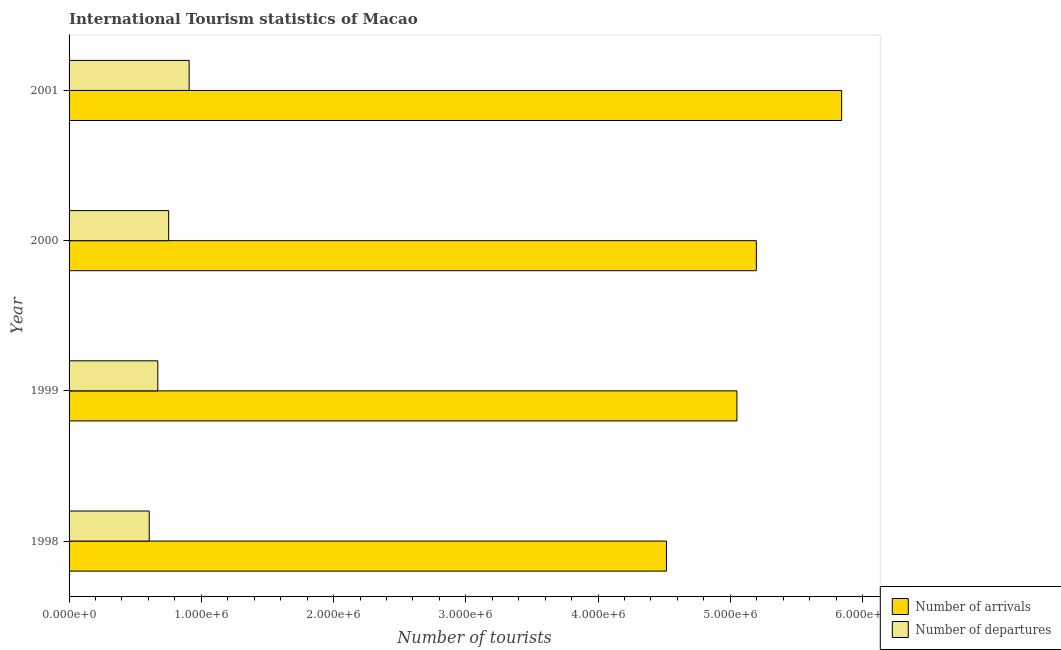Are the number of bars on each tick of the Y-axis equal?
Make the answer very short. Yes. How many bars are there on the 1st tick from the top?
Provide a short and direct response. 2. How many bars are there on the 4th tick from the bottom?
Give a very brief answer. 2. What is the label of the 1st group of bars from the top?
Ensure brevity in your answer.  2001. What is the number of tourist arrivals in 1999?
Your response must be concise. 5.05e+06. Across all years, what is the maximum number of tourist arrivals?
Your answer should be compact. 5.84e+06. Across all years, what is the minimum number of tourist departures?
Your answer should be compact. 6.06e+05. In which year was the number of tourist arrivals maximum?
Your answer should be very brief. 2001. What is the total number of tourist arrivals in the graph?
Your answer should be very brief. 2.06e+07. What is the difference between the number of tourist arrivals in 1998 and that in 2001?
Keep it short and to the point. -1.32e+06. What is the difference between the number of tourist arrivals in 1998 and the number of tourist departures in 2000?
Give a very brief answer. 3.76e+06. What is the average number of tourist arrivals per year?
Your answer should be very brief. 5.15e+06. In the year 1999, what is the difference between the number of tourist arrivals and number of tourist departures?
Your answer should be compact. 4.38e+06. In how many years, is the number of tourist arrivals greater than 400000 ?
Your answer should be very brief. 4. What is the ratio of the number of tourist arrivals in 2000 to that in 2001?
Make the answer very short. 0.89. Is the number of tourist departures in 1998 less than that in 1999?
Offer a very short reply. Yes. Is the difference between the number of tourist departures in 2000 and 2001 greater than the difference between the number of tourist arrivals in 2000 and 2001?
Offer a terse response. Yes. What is the difference between the highest and the second highest number of tourist arrivals?
Keep it short and to the point. 6.45e+05. What is the difference between the highest and the lowest number of tourist arrivals?
Ensure brevity in your answer.  1.32e+06. In how many years, is the number of tourist arrivals greater than the average number of tourist arrivals taken over all years?
Ensure brevity in your answer.  2. Is the sum of the number of tourist arrivals in 2000 and 2001 greater than the maximum number of tourist departures across all years?
Your answer should be very brief. Yes. What does the 1st bar from the top in 1998 represents?
Your answer should be very brief. Number of departures. What does the 1st bar from the bottom in 2001 represents?
Offer a very short reply. Number of arrivals. Are all the bars in the graph horizontal?
Provide a succinct answer. Yes. How many years are there in the graph?
Make the answer very short. 4. Does the graph contain grids?
Keep it short and to the point. No. Where does the legend appear in the graph?
Offer a terse response. Bottom right. How are the legend labels stacked?
Provide a short and direct response. Vertical. What is the title of the graph?
Keep it short and to the point. International Tourism statistics of Macao. Does "Non-pregnant women" appear as one of the legend labels in the graph?
Make the answer very short. No. What is the label or title of the X-axis?
Provide a short and direct response. Number of tourists. What is the label or title of the Y-axis?
Ensure brevity in your answer.  Year. What is the Number of tourists of Number of arrivals in 1998?
Your response must be concise. 4.52e+06. What is the Number of tourists of Number of departures in 1998?
Your response must be concise. 6.06e+05. What is the Number of tourists in Number of arrivals in 1999?
Your answer should be very brief. 5.05e+06. What is the Number of tourists in Number of departures in 1999?
Offer a very short reply. 6.71e+05. What is the Number of tourists of Number of arrivals in 2000?
Offer a very short reply. 5.20e+06. What is the Number of tourists of Number of departures in 2000?
Your response must be concise. 7.53e+05. What is the Number of tourists of Number of arrivals in 2001?
Your answer should be very brief. 5.84e+06. What is the Number of tourists of Number of departures in 2001?
Offer a terse response. 9.08e+05. Across all years, what is the maximum Number of tourists in Number of arrivals?
Your answer should be compact. 5.84e+06. Across all years, what is the maximum Number of tourists in Number of departures?
Make the answer very short. 9.08e+05. Across all years, what is the minimum Number of tourists of Number of arrivals?
Ensure brevity in your answer.  4.52e+06. Across all years, what is the minimum Number of tourists in Number of departures?
Your answer should be compact. 6.06e+05. What is the total Number of tourists of Number of arrivals in the graph?
Offer a terse response. 2.06e+07. What is the total Number of tourists in Number of departures in the graph?
Provide a short and direct response. 2.94e+06. What is the difference between the Number of tourists of Number of arrivals in 1998 and that in 1999?
Your answer should be very brief. -5.33e+05. What is the difference between the Number of tourists of Number of departures in 1998 and that in 1999?
Keep it short and to the point. -6.50e+04. What is the difference between the Number of tourists of Number of arrivals in 1998 and that in 2000?
Offer a terse response. -6.80e+05. What is the difference between the Number of tourists in Number of departures in 1998 and that in 2000?
Make the answer very short. -1.47e+05. What is the difference between the Number of tourists in Number of arrivals in 1998 and that in 2001?
Give a very brief answer. -1.32e+06. What is the difference between the Number of tourists of Number of departures in 1998 and that in 2001?
Offer a very short reply. -3.02e+05. What is the difference between the Number of tourists of Number of arrivals in 1999 and that in 2000?
Provide a short and direct response. -1.47e+05. What is the difference between the Number of tourists in Number of departures in 1999 and that in 2000?
Offer a very short reply. -8.20e+04. What is the difference between the Number of tourists of Number of arrivals in 1999 and that in 2001?
Give a very brief answer. -7.92e+05. What is the difference between the Number of tourists of Number of departures in 1999 and that in 2001?
Provide a succinct answer. -2.37e+05. What is the difference between the Number of tourists of Number of arrivals in 2000 and that in 2001?
Your answer should be very brief. -6.45e+05. What is the difference between the Number of tourists in Number of departures in 2000 and that in 2001?
Make the answer very short. -1.55e+05. What is the difference between the Number of tourists of Number of arrivals in 1998 and the Number of tourists of Number of departures in 1999?
Your response must be concise. 3.85e+06. What is the difference between the Number of tourists in Number of arrivals in 1998 and the Number of tourists in Number of departures in 2000?
Offer a terse response. 3.76e+06. What is the difference between the Number of tourists in Number of arrivals in 1998 and the Number of tourists in Number of departures in 2001?
Provide a short and direct response. 3.61e+06. What is the difference between the Number of tourists of Number of arrivals in 1999 and the Number of tourists of Number of departures in 2000?
Keep it short and to the point. 4.30e+06. What is the difference between the Number of tourists of Number of arrivals in 1999 and the Number of tourists of Number of departures in 2001?
Give a very brief answer. 4.14e+06. What is the difference between the Number of tourists in Number of arrivals in 2000 and the Number of tourists in Number of departures in 2001?
Give a very brief answer. 4.29e+06. What is the average Number of tourists of Number of arrivals per year?
Offer a terse response. 5.15e+06. What is the average Number of tourists in Number of departures per year?
Ensure brevity in your answer.  7.34e+05. In the year 1998, what is the difference between the Number of tourists in Number of arrivals and Number of tourists in Number of departures?
Keep it short and to the point. 3.91e+06. In the year 1999, what is the difference between the Number of tourists in Number of arrivals and Number of tourists in Number of departures?
Keep it short and to the point. 4.38e+06. In the year 2000, what is the difference between the Number of tourists in Number of arrivals and Number of tourists in Number of departures?
Offer a very short reply. 4.44e+06. In the year 2001, what is the difference between the Number of tourists in Number of arrivals and Number of tourists in Number of departures?
Provide a succinct answer. 4.93e+06. What is the ratio of the Number of tourists in Number of arrivals in 1998 to that in 1999?
Provide a succinct answer. 0.89. What is the ratio of the Number of tourists in Number of departures in 1998 to that in 1999?
Your response must be concise. 0.9. What is the ratio of the Number of tourists in Number of arrivals in 1998 to that in 2000?
Provide a succinct answer. 0.87. What is the ratio of the Number of tourists of Number of departures in 1998 to that in 2000?
Your response must be concise. 0.8. What is the ratio of the Number of tourists in Number of arrivals in 1998 to that in 2001?
Make the answer very short. 0.77. What is the ratio of the Number of tourists of Number of departures in 1998 to that in 2001?
Your answer should be very brief. 0.67. What is the ratio of the Number of tourists in Number of arrivals in 1999 to that in 2000?
Make the answer very short. 0.97. What is the ratio of the Number of tourists of Number of departures in 1999 to that in 2000?
Your answer should be compact. 0.89. What is the ratio of the Number of tourists of Number of arrivals in 1999 to that in 2001?
Give a very brief answer. 0.86. What is the ratio of the Number of tourists in Number of departures in 1999 to that in 2001?
Keep it short and to the point. 0.74. What is the ratio of the Number of tourists in Number of arrivals in 2000 to that in 2001?
Provide a succinct answer. 0.89. What is the ratio of the Number of tourists of Number of departures in 2000 to that in 2001?
Ensure brevity in your answer.  0.83. What is the difference between the highest and the second highest Number of tourists in Number of arrivals?
Make the answer very short. 6.45e+05. What is the difference between the highest and the second highest Number of tourists in Number of departures?
Make the answer very short. 1.55e+05. What is the difference between the highest and the lowest Number of tourists in Number of arrivals?
Provide a short and direct response. 1.32e+06. What is the difference between the highest and the lowest Number of tourists of Number of departures?
Offer a terse response. 3.02e+05. 